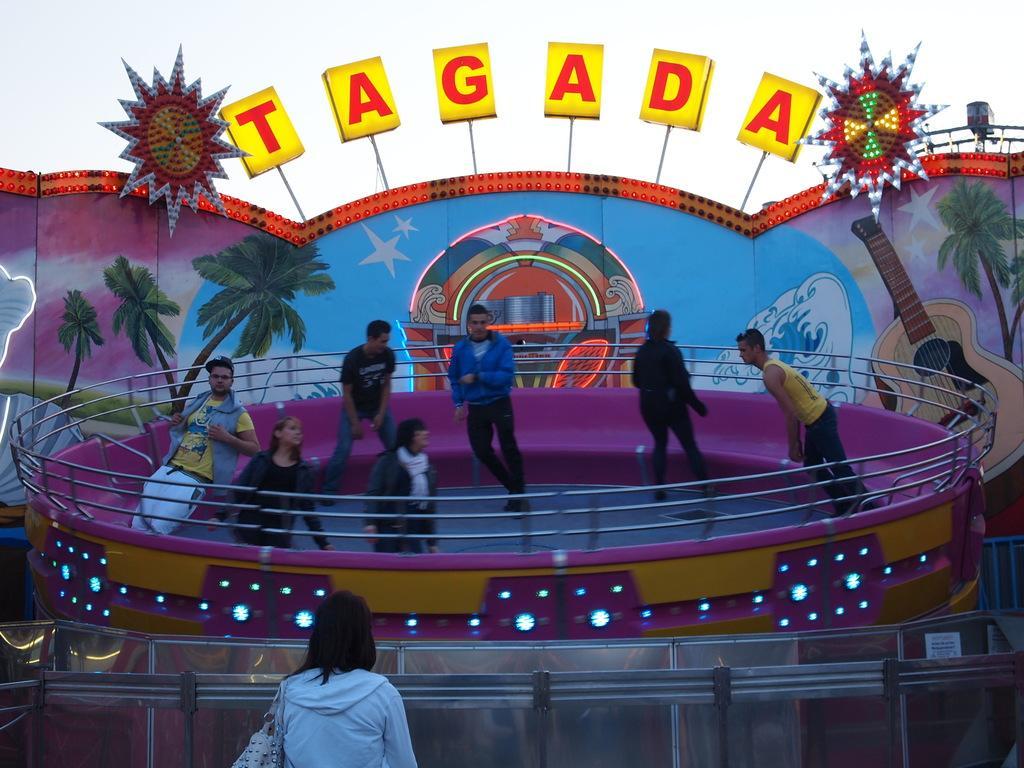Describe this image in one or two sentences. In this picture we can see some people are standing, there is railing in the middle, there is some text in the background, we can also see images of trees in the background, there is another person in the front. 